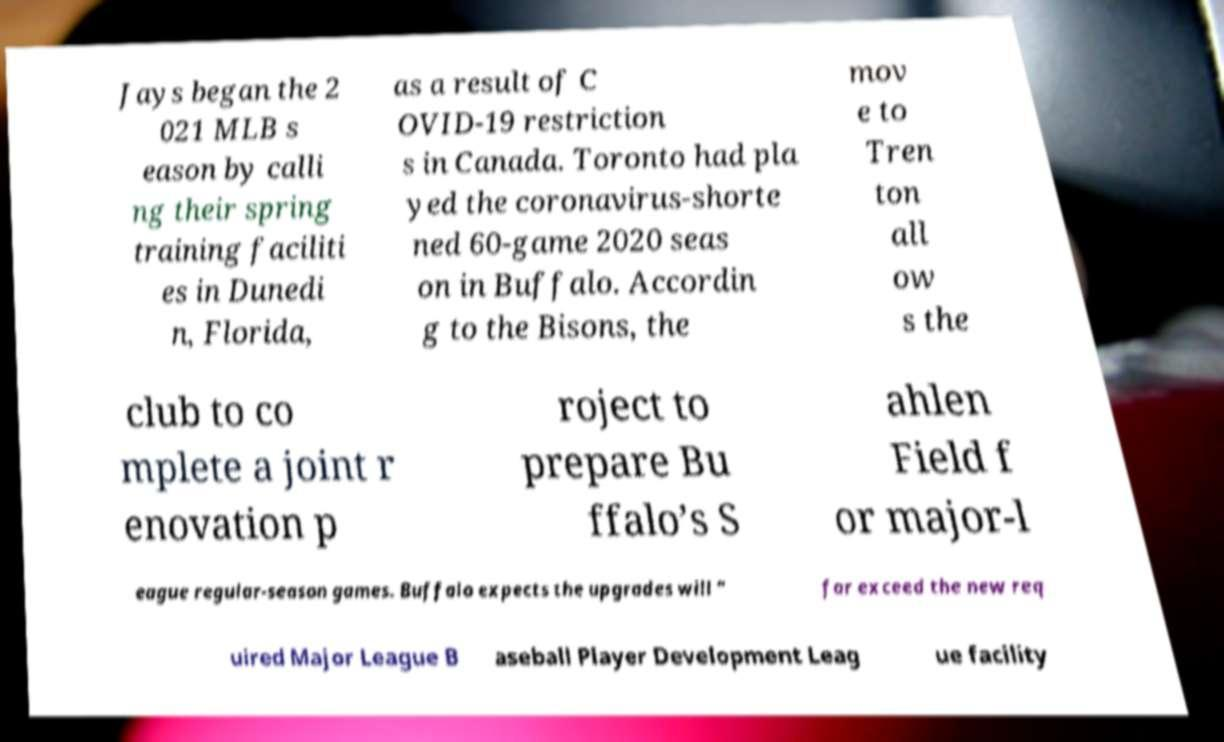I need the written content from this picture converted into text. Can you do that? Jays began the 2 021 MLB s eason by calli ng their spring training faciliti es in Dunedi n, Florida, as a result of C OVID-19 restriction s in Canada. Toronto had pla yed the coronavirus-shorte ned 60-game 2020 seas on in Buffalo. Accordin g to the Bisons, the mov e to Tren ton all ow s the club to co mplete a joint r enovation p roject to prepare Bu ffalo’s S ahlen Field f or major-l eague regular-season games. Buffalo expects the upgrades will “ far exceed the new req uired Major League B aseball Player Development Leag ue facility 